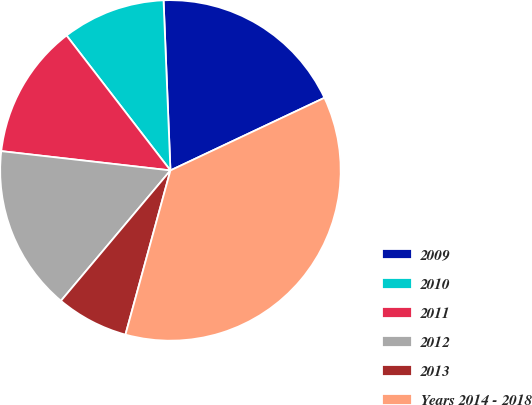Convert chart to OTSL. <chart><loc_0><loc_0><loc_500><loc_500><pie_chart><fcel>2009<fcel>2010<fcel>2011<fcel>2012<fcel>2013<fcel>Years 2014 - 2018<nl><fcel>18.63%<fcel>9.8%<fcel>12.75%<fcel>15.69%<fcel>6.86%<fcel>36.27%<nl></chart> 